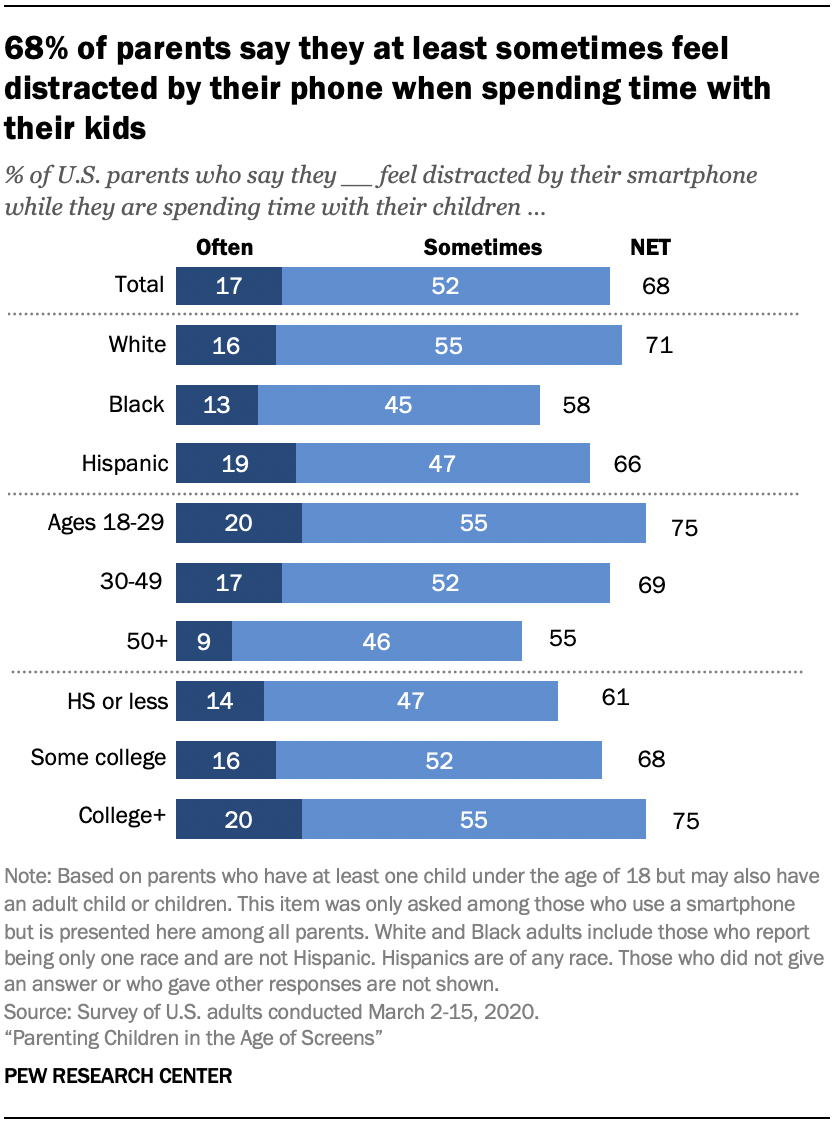Give some essential details in this illustration. The total for Often is 17. The difference between 'Sometimes' and 'Often' is the frequency with which an action or event occurs, with 'Sometimes' indicating a less frequent occurrence and 'Often' indicating a more frequent occurrence. 